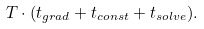Convert formula to latex. <formula><loc_0><loc_0><loc_500><loc_500>T \cdot ( t _ { g r a d } + t _ { c o n s t } + t _ { s o l v e } ) .</formula> 